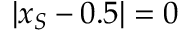<formula> <loc_0><loc_0><loc_500><loc_500>| x _ { S } - 0 . 5 | = 0</formula> 